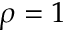<formula> <loc_0><loc_0><loc_500><loc_500>\rho = 1</formula> 